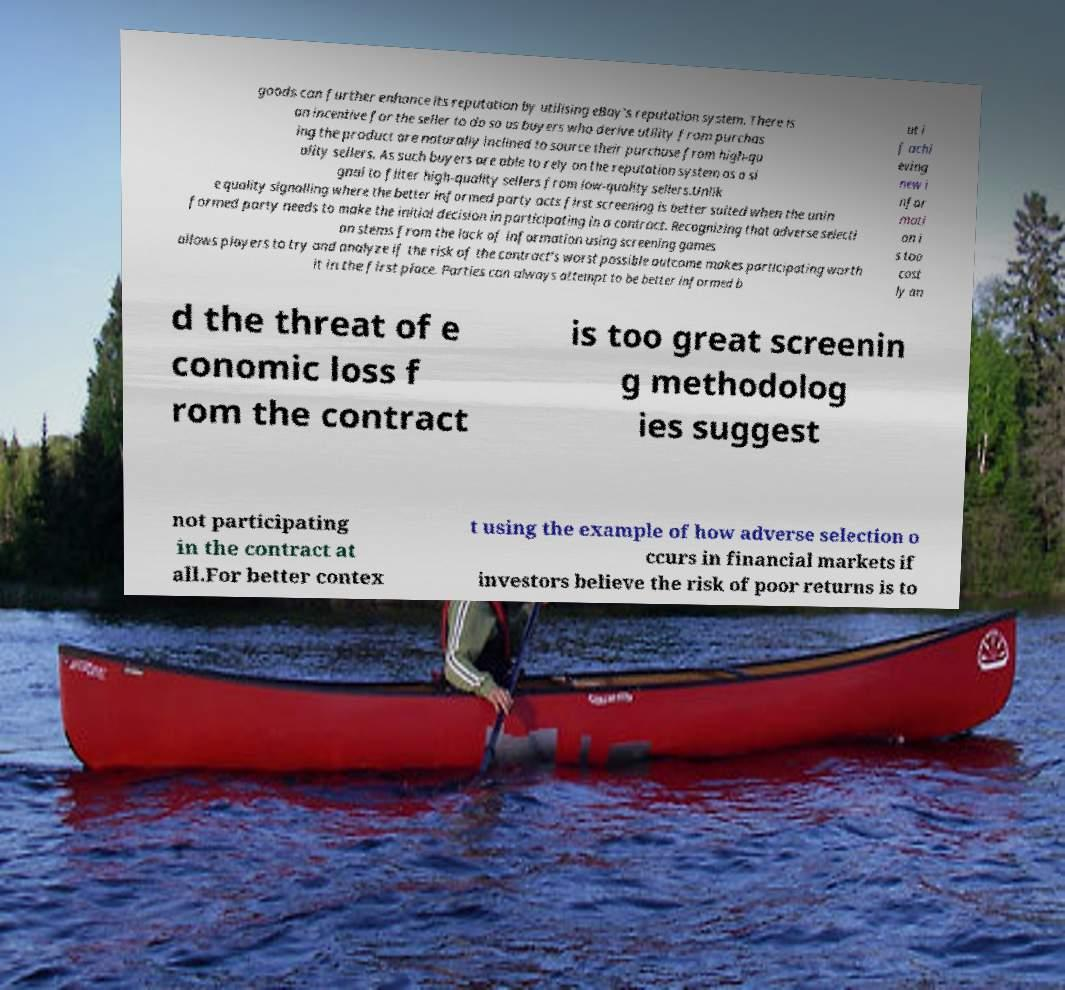Can you read and provide the text displayed in the image?This photo seems to have some interesting text. Can you extract and type it out for me? goods can further enhance its reputation by utilising eBay's reputation system. There is an incentive for the seller to do so as buyers who derive utility from purchas ing the product are naturally inclined to source their purchase from high-qu ality sellers. As such buyers are able to rely on the reputation system as a si gnal to filter high-quality sellers from low-quality sellers.Unlik e quality signalling where the better informed party acts first screening is better suited when the unin formed party needs to make the initial decision in participating in a contract. Recognizing that adverse selecti on stems from the lack of information using screening games allows players to try and analyze if the risk of the contract's worst possible outcome makes participating worth it in the first place. Parties can always attempt to be better informed b ut i f achi eving new i nfor mati on i s too cost ly an d the threat of e conomic loss f rom the contract is too great screenin g methodolog ies suggest not participating in the contract at all.For better contex t using the example of how adverse selection o ccurs in financial markets if investors believe the risk of poor returns is to 